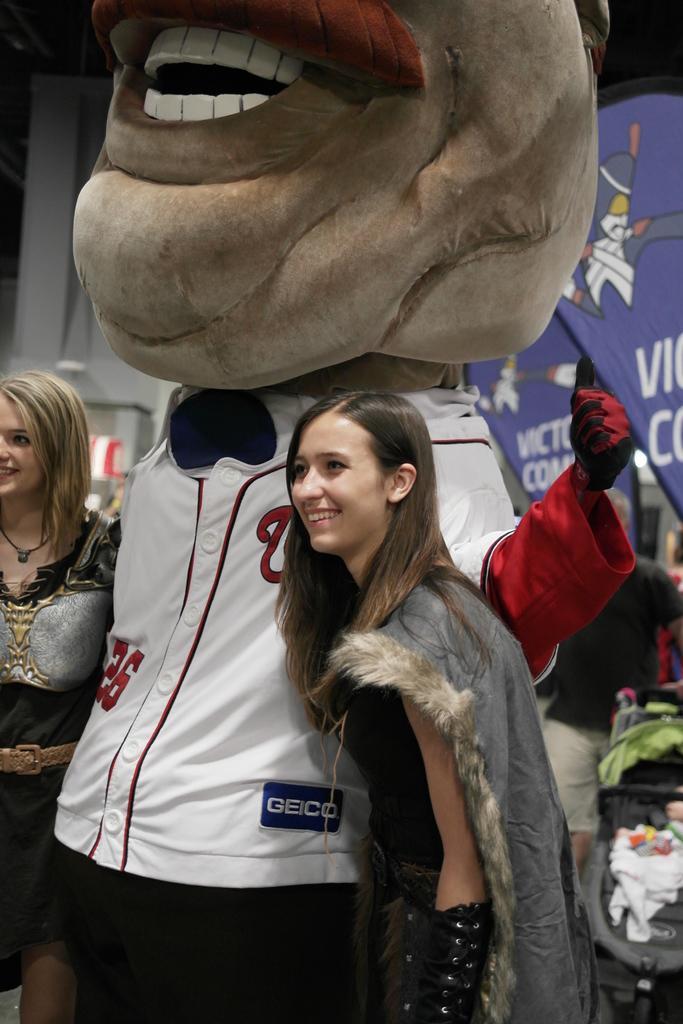Please provide a concise description of this image. In this image there are two women standing. They are wearing costumes and they are smiling. In between them there is a person wearing a costume. To the right there is another person standing. In the background there are banners to the wall. There is text on the banners. 